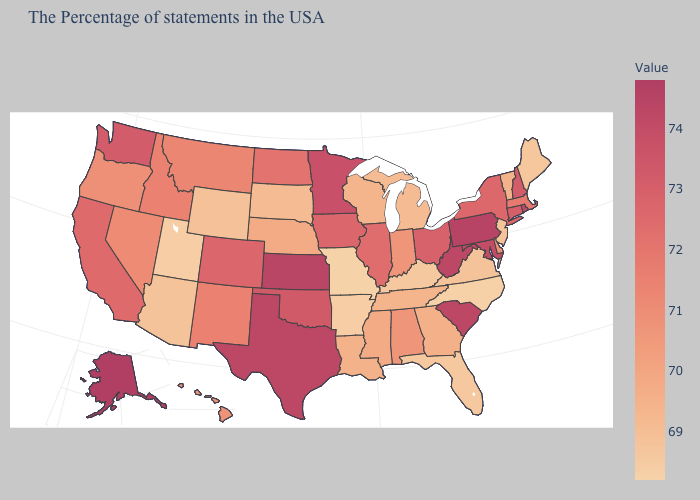Among the states that border Massachusetts , which have the highest value?
Keep it brief. Rhode Island. Does North Carolina have the highest value in the South?
Give a very brief answer. No. Does Georgia have the lowest value in the USA?
Answer briefly. No. Among the states that border West Virginia , which have the lowest value?
Be succinct. Kentucky. 